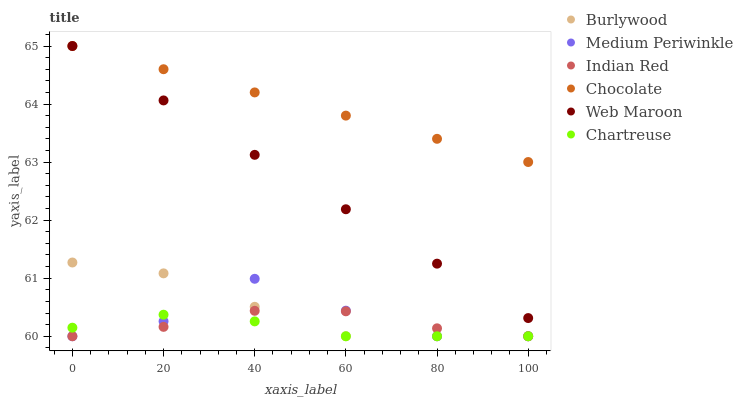Does Chartreuse have the minimum area under the curve?
Answer yes or no. Yes. Does Chocolate have the maximum area under the curve?
Answer yes or no. Yes. Does Medium Periwinkle have the minimum area under the curve?
Answer yes or no. No. Does Medium Periwinkle have the maximum area under the curve?
Answer yes or no. No. Is Web Maroon the smoothest?
Answer yes or no. Yes. Is Medium Periwinkle the roughest?
Answer yes or no. Yes. Is Medium Periwinkle the smoothest?
Answer yes or no. No. Is Web Maroon the roughest?
Answer yes or no. No. Does Burlywood have the lowest value?
Answer yes or no. Yes. Does Web Maroon have the lowest value?
Answer yes or no. No. Does Chocolate have the highest value?
Answer yes or no. Yes. Does Medium Periwinkle have the highest value?
Answer yes or no. No. Is Chartreuse less than Web Maroon?
Answer yes or no. Yes. Is Web Maroon greater than Medium Periwinkle?
Answer yes or no. Yes. Does Chartreuse intersect Medium Periwinkle?
Answer yes or no. Yes. Is Chartreuse less than Medium Periwinkle?
Answer yes or no. No. Is Chartreuse greater than Medium Periwinkle?
Answer yes or no. No. Does Chartreuse intersect Web Maroon?
Answer yes or no. No. 